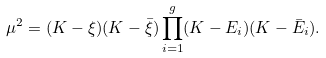Convert formula to latex. <formula><loc_0><loc_0><loc_500><loc_500>\mu ^ { 2 } = ( K - \xi ) ( K - \bar { \xi } ) \prod _ { i = 1 } ^ { g } ( K - E _ { i } ) ( K - \bar { E } _ { i } ) .</formula> 